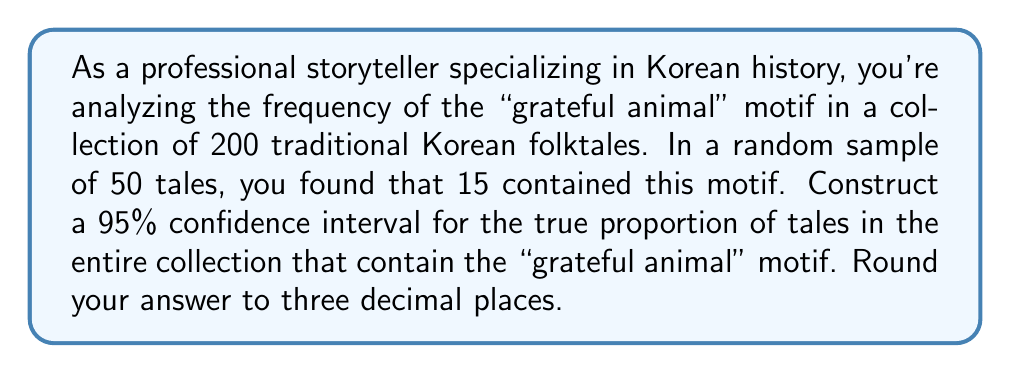What is the answer to this math problem? Let's approach this step-by-step:

1) We're dealing with a proportion, so we'll use the formula for a confidence interval for a proportion:

   $$\hat{p} \pm z^* \sqrt{\frac{\hat{p}(1-\hat{p})}{n}}$$

   Where:
   $\hat{p}$ is the sample proportion
   $z^*$ is the critical value for the desired confidence level
   $n$ is the sample size

2) Calculate $\hat{p}$:
   $\hat{p} = \frac{15}{50} = 0.3$

3) For a 95% confidence interval, $z^* = 1.96$

4) Now, let's plug these values into our formula:

   $$0.3 \pm 1.96 \sqrt{\frac{0.3(1-0.3)}{50}}$$

5) Simplify inside the square root:

   $$0.3 \pm 1.96 \sqrt{\frac{0.3(0.7)}{50}} = 0.3 \pm 1.96 \sqrt{\frac{0.21}{50}}$$

6) Calculate:

   $$0.3 \pm 1.96 \sqrt{0.0042} = 0.3 \pm 1.96(0.0648) = 0.3 \pm 0.1270$$

7) Therefore, the confidence interval is:

   $$(0.3 - 0.1270, 0.3 + 0.1270) = (0.1730, 0.4270)$$

8) Rounding to three decimal places:

   $$(0.173, 0.427)$$

This means we can be 95% confident that the true proportion of tales in the entire collection containing the "grateful animal" motif is between 0.173 and 0.427, or between 17.3% and 42.7%.
Answer: (0.173, 0.427) 